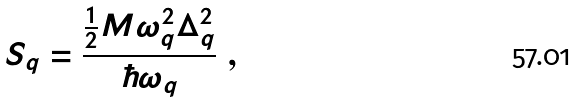Convert formula to latex. <formula><loc_0><loc_0><loc_500><loc_500>S _ { q } = \frac { \frac { 1 } { 2 } M \omega _ { q } ^ { 2 } \Delta _ { q } ^ { 2 } } { \hbar { \omega } _ { q } } \ ,</formula> 